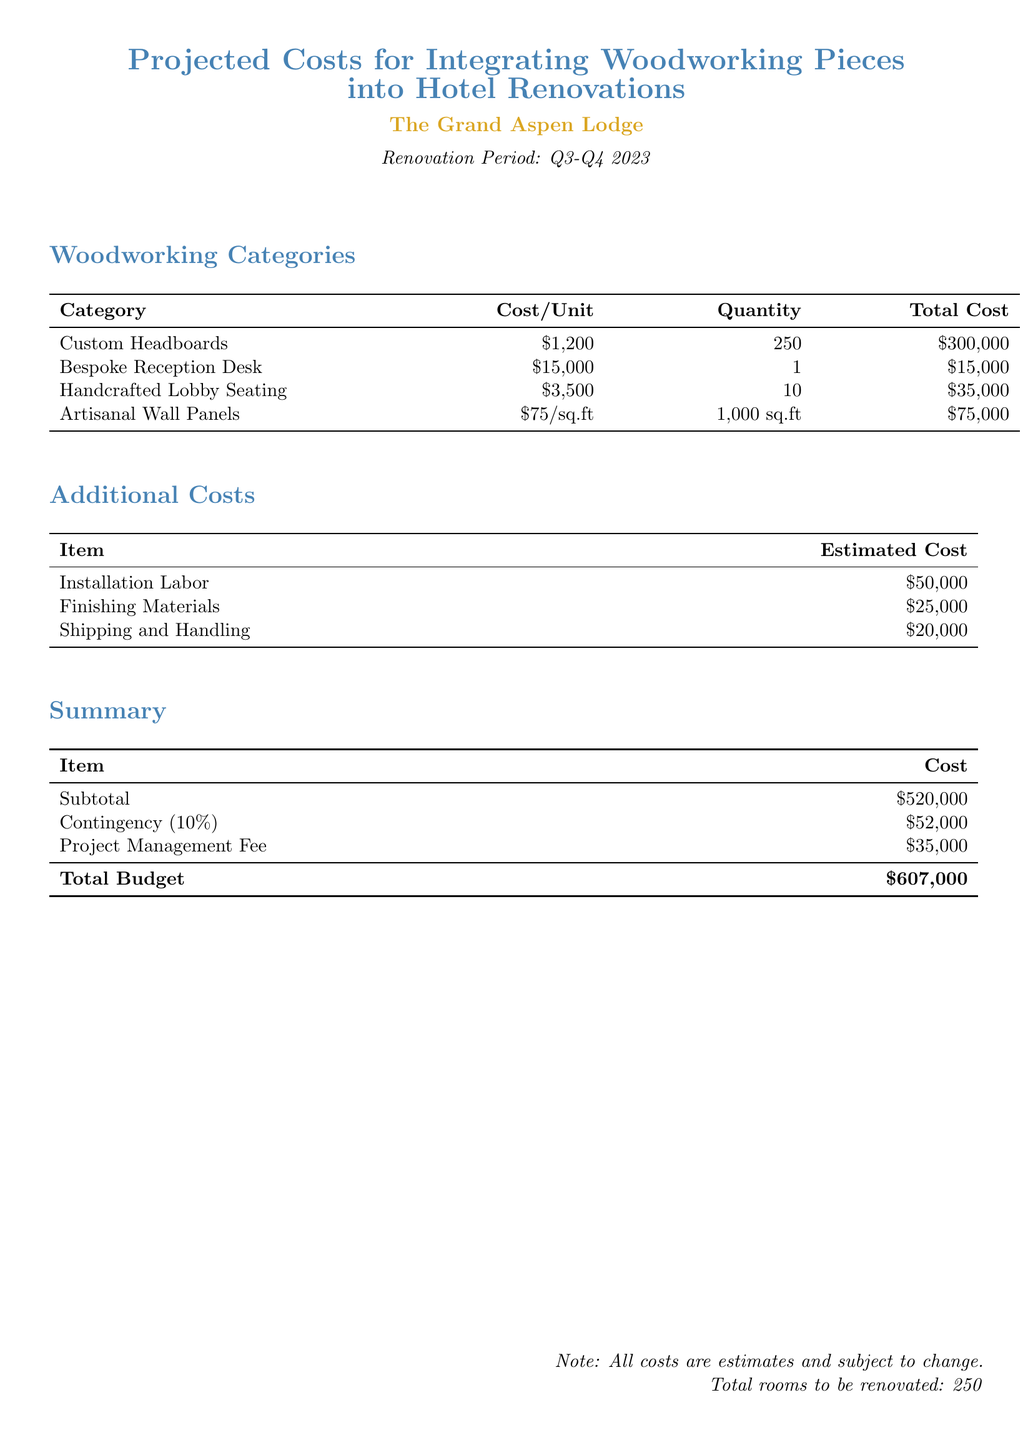What is the total budget for the project? The total budget is the final amount after all calculations are added, which includes subtotal, contingency, and project management fee.
Answer: $607,000 What is the cost for the Bespoke Reception Desk? The document lists the cost for the Bespoke Reception Desk specifically as part of the woodworking categories.
Answer: $15,000 How many Custom Headboards are being produced? The quantity of Custom Headboards is provided in the woodworking categories section of the document.
Answer: 250 What is the estimated cost of installation labor? The cost for installation labor is itemized in the additional costs section of the budget.
Answer: $50,000 What percentage is the contingency based on subtotal? The contingency is detailed as a percentage of the subtotal provided in the summary section.
Answer: 10% What is the cost per square foot for Artisanal Wall Panels? The cost of Artisanal Wall Panels is mentioned as a price per square foot in woodworking categories.
Answer: $75/sq.ft How much is allocated for project management fees? The project management fee is listed as a separate item in the summary of the document.
Answer: $35,000 What is the estimated cost for finishing materials? The estimated cost for finishing materials is included under additional costs.
Answer: $25,000 